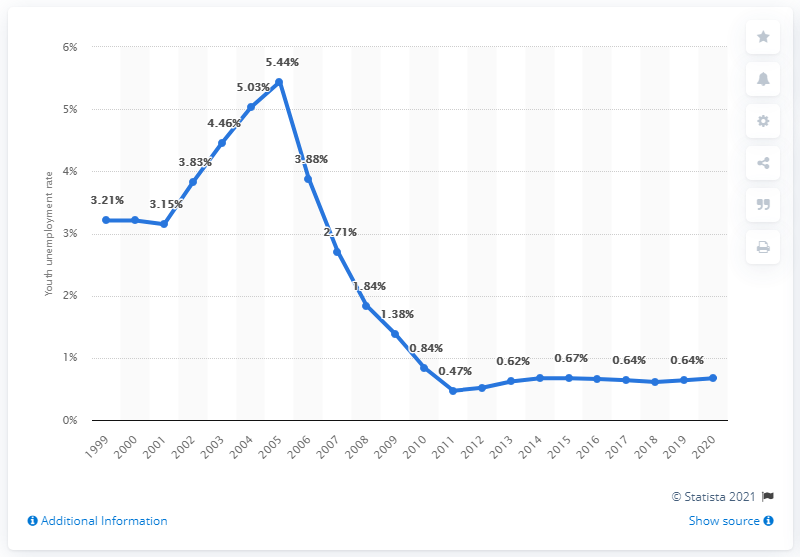Point out several critical features in this image. The youth unemployment rate in Niger in 2020 was 0.67%. 